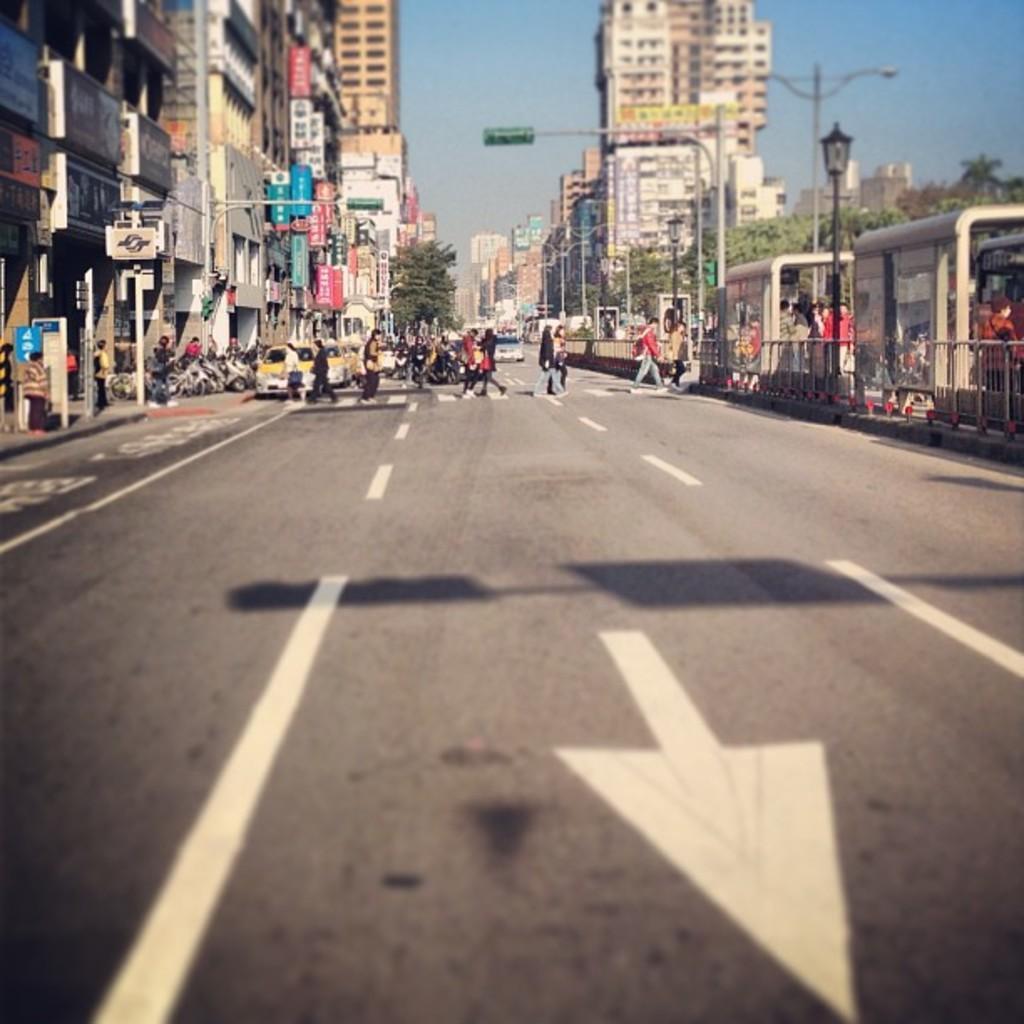Can you describe this image briefly? In this image there are a few vehicles moving on the road and few people are crossing the road. On the left and right side of the image there are buildings and trees, in front of the buildings there are a few poles, boards and street lights. In the background there is the sky. 